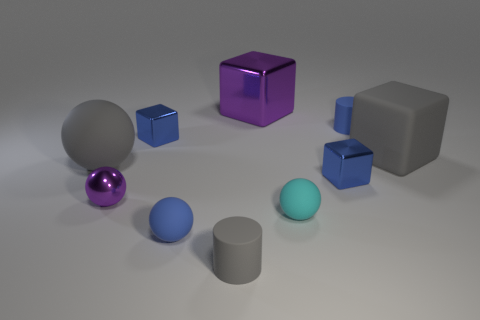What size is the rubber cylinder that is the same color as the large rubber ball? The rubber cylinder sharing the same color as the large rubber ball is medium-sized in comparison to other cylinders and balls in the image. 